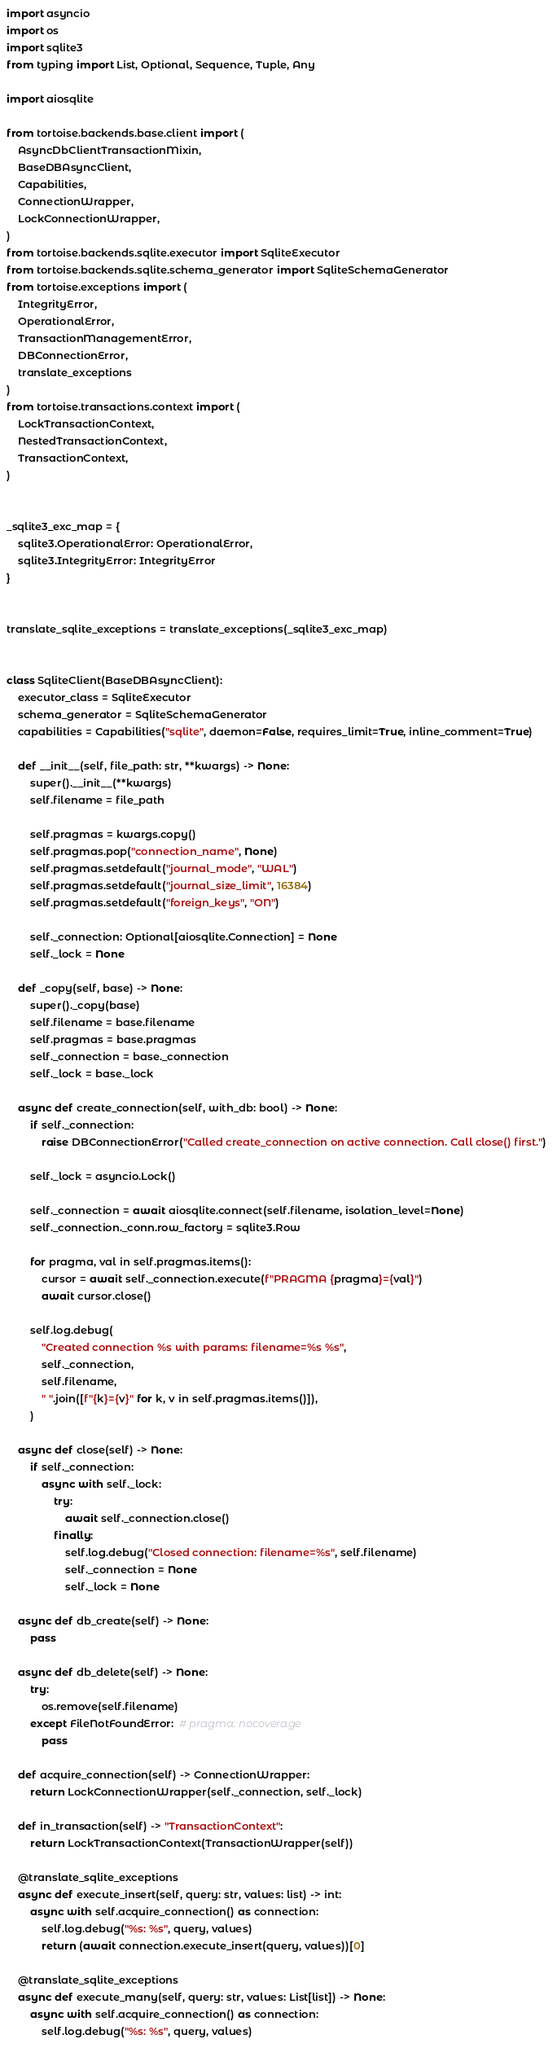<code> <loc_0><loc_0><loc_500><loc_500><_Python_>
import asyncio
import os
import sqlite3
from typing import List, Optional, Sequence, Tuple, Any

import aiosqlite

from tortoise.backends.base.client import (
    AsyncDbClientTransactionMixin,
    BaseDBAsyncClient,
    Capabilities,
    ConnectionWrapper,
    LockConnectionWrapper,
)
from tortoise.backends.sqlite.executor import SqliteExecutor
from tortoise.backends.sqlite.schema_generator import SqliteSchemaGenerator
from tortoise.exceptions import (
    IntegrityError,
    OperationalError,
    TransactionManagementError,
    DBConnectionError,
    translate_exceptions
)
from tortoise.transactions.context import (
    LockTransactionContext,
    NestedTransactionContext,
    TransactionContext,
)


_sqlite3_exc_map = {
    sqlite3.OperationalError: OperationalError,
    sqlite3.IntegrityError: IntegrityError
}


translate_sqlite_exceptions = translate_exceptions(_sqlite3_exc_map)


class SqliteClient(BaseDBAsyncClient):
    executor_class = SqliteExecutor
    schema_generator = SqliteSchemaGenerator
    capabilities = Capabilities("sqlite", daemon=False, requires_limit=True, inline_comment=True)

    def __init__(self, file_path: str, **kwargs) -> None:
        super().__init__(**kwargs)
        self.filename = file_path

        self.pragmas = kwargs.copy()
        self.pragmas.pop("connection_name", None)
        self.pragmas.setdefault("journal_mode", "WAL")
        self.pragmas.setdefault("journal_size_limit", 16384)
        self.pragmas.setdefault("foreign_keys", "ON")

        self._connection: Optional[aiosqlite.Connection] = None
        self._lock = None

    def _copy(self, base) -> None:
        super()._copy(base)
        self.filename = base.filename
        self.pragmas = base.pragmas
        self._connection = base._connection
        self._lock = base._lock

    async def create_connection(self, with_db: bool) -> None:
        if self._connection:
            raise DBConnectionError("Called create_connection on active connection. Call close() first.")

        self._lock = asyncio.Lock()

        self._connection = await aiosqlite.connect(self.filename, isolation_level=None)
        self._connection._conn.row_factory = sqlite3.Row

        for pragma, val in self.pragmas.items():
            cursor = await self._connection.execute(f"PRAGMA {pragma}={val}")
            await cursor.close()

        self.log.debug(
            "Created connection %s with params: filename=%s %s",
            self._connection,
            self.filename,
            " ".join([f"{k}={v}" for k, v in self.pragmas.items()]),
        )

    async def close(self) -> None:
        if self._connection:
            async with self._lock:
                try:
                    await self._connection.close()
                finally:
                    self.log.debug("Closed connection: filename=%s", self.filename)
                    self._connection = None
                    self._lock = None

    async def db_create(self) -> None:
        pass

    async def db_delete(self) -> None:
        try:
            os.remove(self.filename)
        except FileNotFoundError:  # pragma: nocoverage
            pass

    def acquire_connection(self) -> ConnectionWrapper:
        return LockConnectionWrapper(self._connection, self._lock)

    def in_transaction(self) -> "TransactionContext":
        return LockTransactionContext(TransactionWrapper(self))

    @translate_sqlite_exceptions
    async def execute_insert(self, query: str, values: list) -> int:
        async with self.acquire_connection() as connection:
            self.log.debug("%s: %s", query, values)
            return (await connection.execute_insert(query, values))[0]

    @translate_sqlite_exceptions
    async def execute_many(self, query: str, values: List[list]) -> None:
        async with self.acquire_connection() as connection:
            self.log.debug("%s: %s", query, values)</code> 